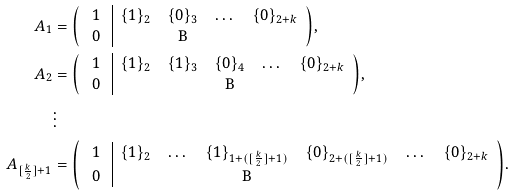<formula> <loc_0><loc_0><loc_500><loc_500>A _ { 1 } & = { \left ( \begin{array} { c | c c c c } 1 & \{ 1 \} _ { 2 } & \{ 0 \} _ { 3 } & \dots & \{ 0 \} _ { 2 + k } \\ $ 0 $ & & $ B $ & \end{array} \right ) } , \\ A _ { 2 } & = { \left ( \begin{array} { c | c c c c c } 1 & \{ 1 \} _ { 2 } & \{ 1 \} _ { 3 } & \{ 0 \} _ { 4 } & \dots & \{ 0 \} _ { 2 + k } \\ $ 0 $ & & & $ B $ & \end{array} \right ) } , \\ & \vdots \\ A _ { [ \frac { k } { 2 } ] + 1 } & = { \left ( \begin{array} { c | c c c c c c } 1 & \{ 1 \} _ { 2 } & \dots & \{ 1 \} _ { 1 + ( [ \frac { k } { 2 } ] + 1 ) } & \{ 0 \} _ { 2 + ( [ \frac { k } { 2 } ] + 1 ) } & \dots & \{ 0 \} _ { 2 + k } \\ $ 0 $ & & & $ B $ & \end{array} \right ) } .</formula> 